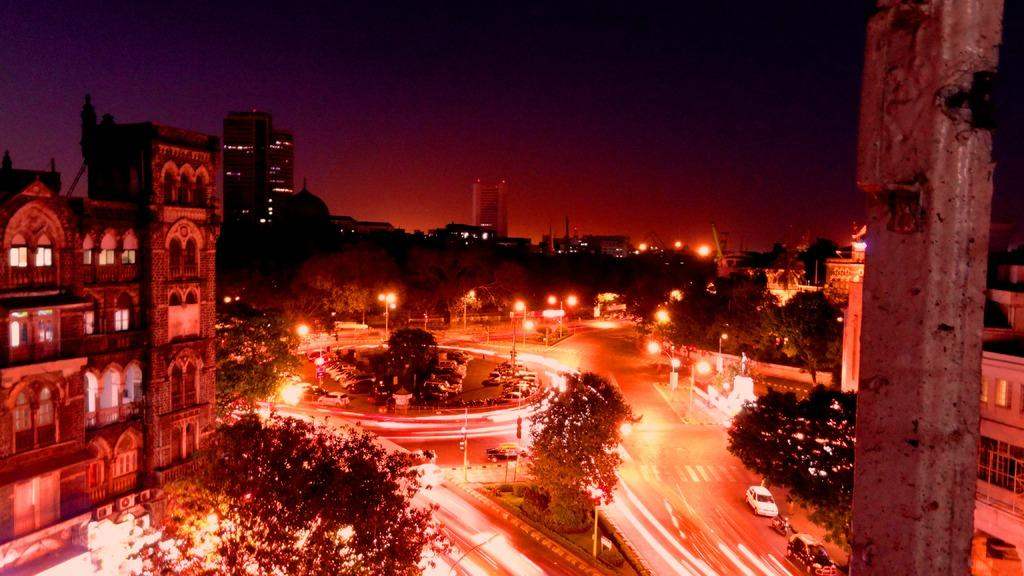What type of structures can be seen in the image? There are buildings in the image. What other natural elements are present in the image? There are trees in the image. What type of lighting is present in the image? There are pole lights in the image. What type of transportation can be seen in the image? There are cars on the road in the image. How would you describe the weather in the image? The sky is cloudy in the image. Can you see the crook trying to steal a shop in the image? There is no crook or shop present in the image. How many fangs can be seen on the pole lights in the image? The pole lights in the image do not have fangs; they are lighting fixtures. 